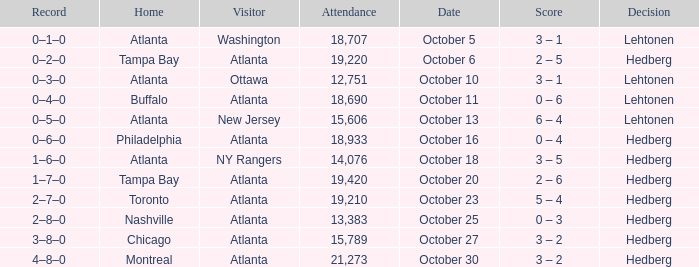What was the record on the game that was played on october 27? 3–8–0. 